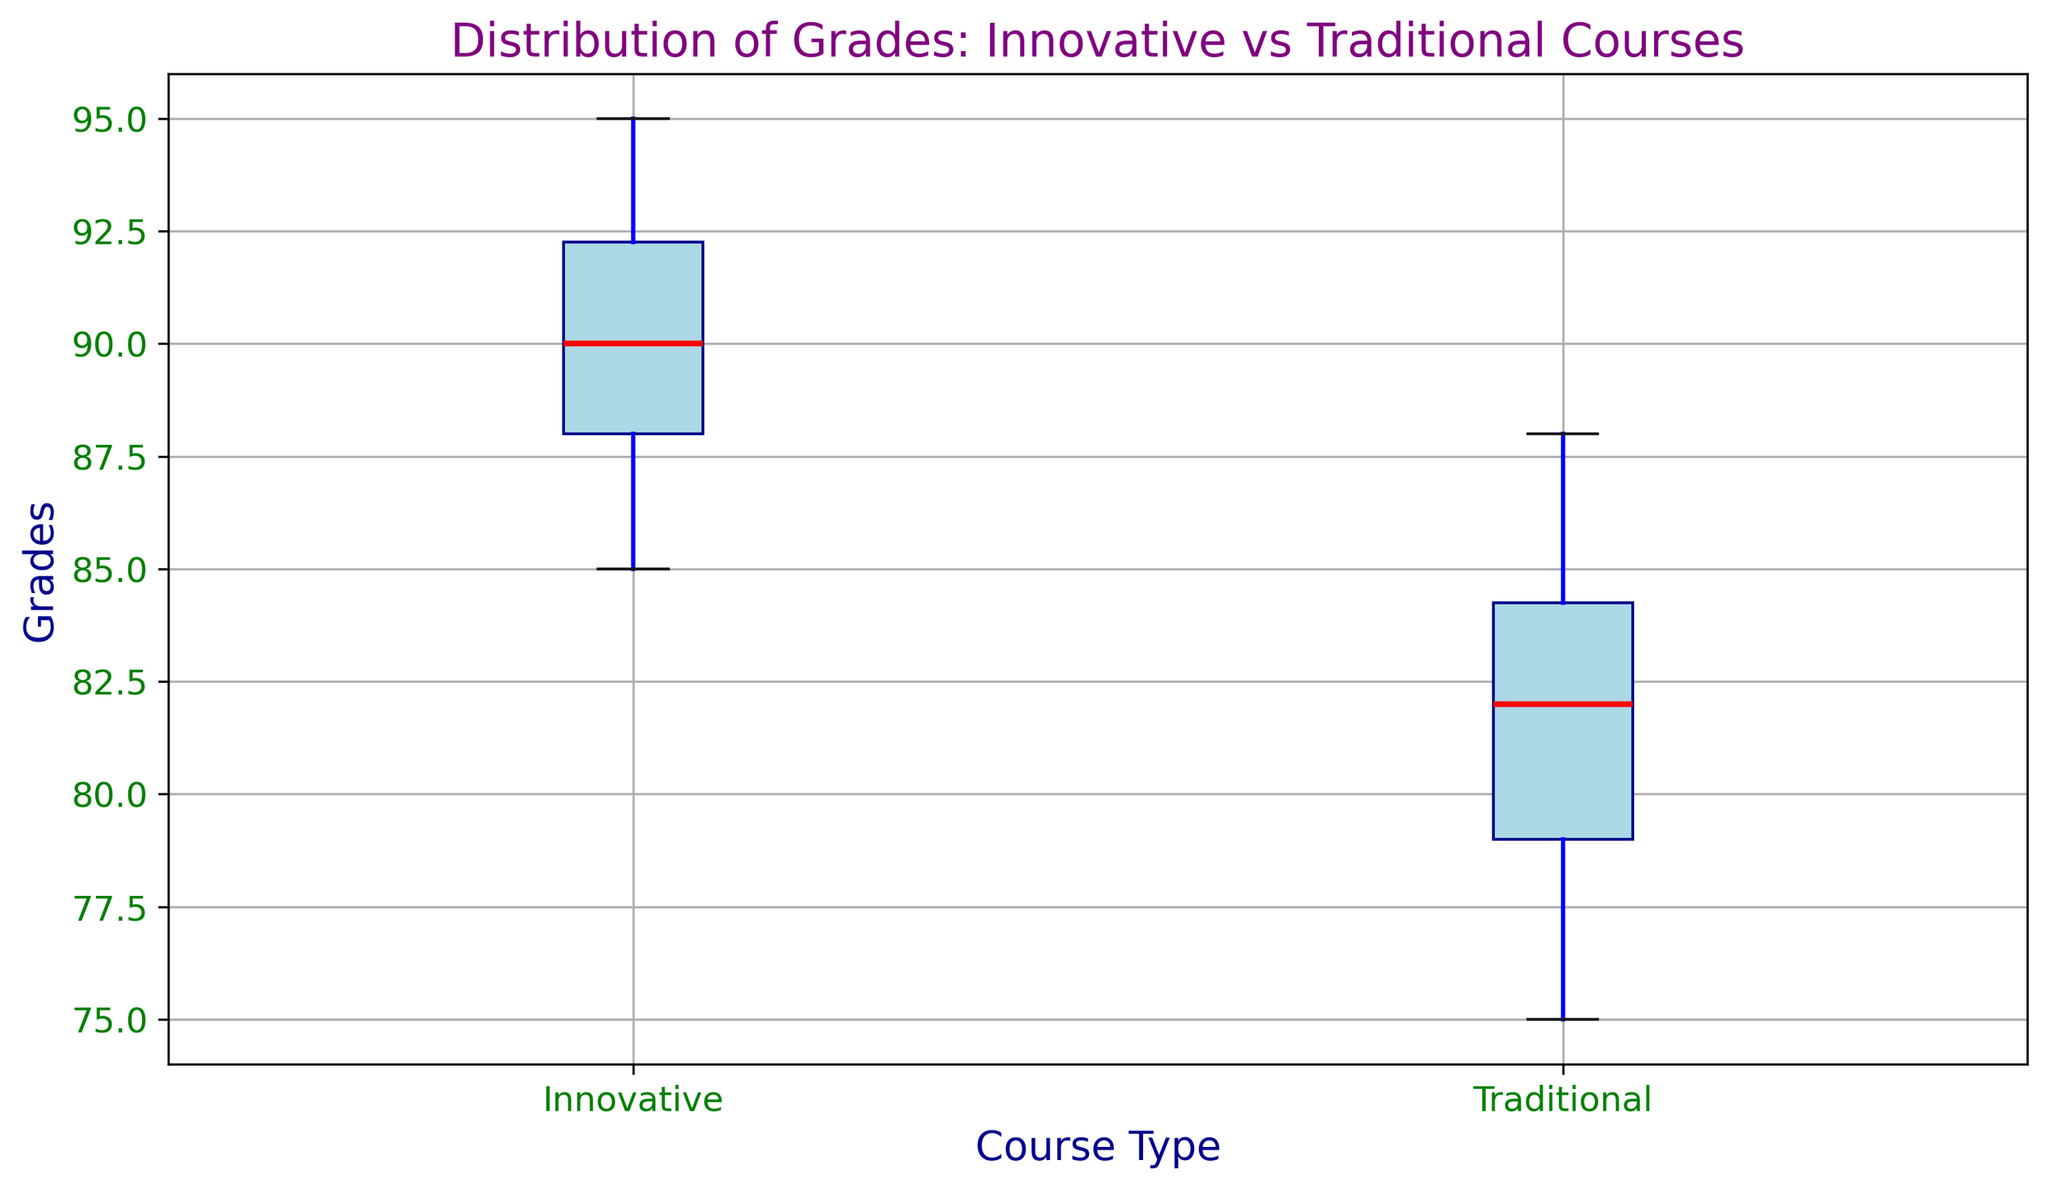What's the median grade in the innovative courses? The median grade is marked by the red line inside the box for the "Innovative" group. Locating this line on the y-axis shows the value.
Answer: 90 Which course type has a higher median grade, innovative or traditional? Compare the red lines (medians) inside the boxes for both "Innovative" and "Traditional" groups. The red line for innovative courses is higher on the y-axis than that for traditional courses.
Answer: Innovative What's the interquartile range (IQR) for traditional courses? The IQR is the difference between the third quartile (top edge of the box) and the first quartile (bottom edge of the box). For traditional courses, these values are approximately 85 and 78. Calculating the difference: 85 - 78.
Answer: 7 Are there any outliers in the grade distributions? Look for any data points represented as individual markers outside the whiskers of each box plot. There don't appear to be any such markers in either course type.
Answer: No Which course type has a greater variability in grades? The variability can be inferred from the height of the boxes and the length of the whiskers. The box and whisker lengths for traditional courses seem slightly longer.
Answer: Traditional How does the upper quartile of innovative courses compare to the upper quartile of traditional courses? Check the top edges of the boxes for both "Innovative" and "Traditional" groups. The top edge of the box for innovative courses is higher on the y-axis than that for traditional courses.
Answer: Higher for Innovative What is the maximum grade for the innovative courses, and how does it compare to the maximum grade for the traditional courses? The maximum grade can be identified by the top whisker for each course type. The whisker for innovative courses appears to reach 95, while the whisker for traditional courses reaches 88.
Answer: 95 for Innovative, higher than Traditional What is the median grade difference between innovative and traditional courses? Locate the red lines (medians) for both "Innovative" and "Traditional" groups. The median for innovative is 90 and for traditional is around 82. Calculate the difference: 90 - 82.
Answer: 8 Which course type has a lower minimum grade? The minimum grade is indicated by the bottom whisker for each box plot. For traditional courses, the whisker reaches 75, while for innovative it reaches 85.
Answer: Traditional 